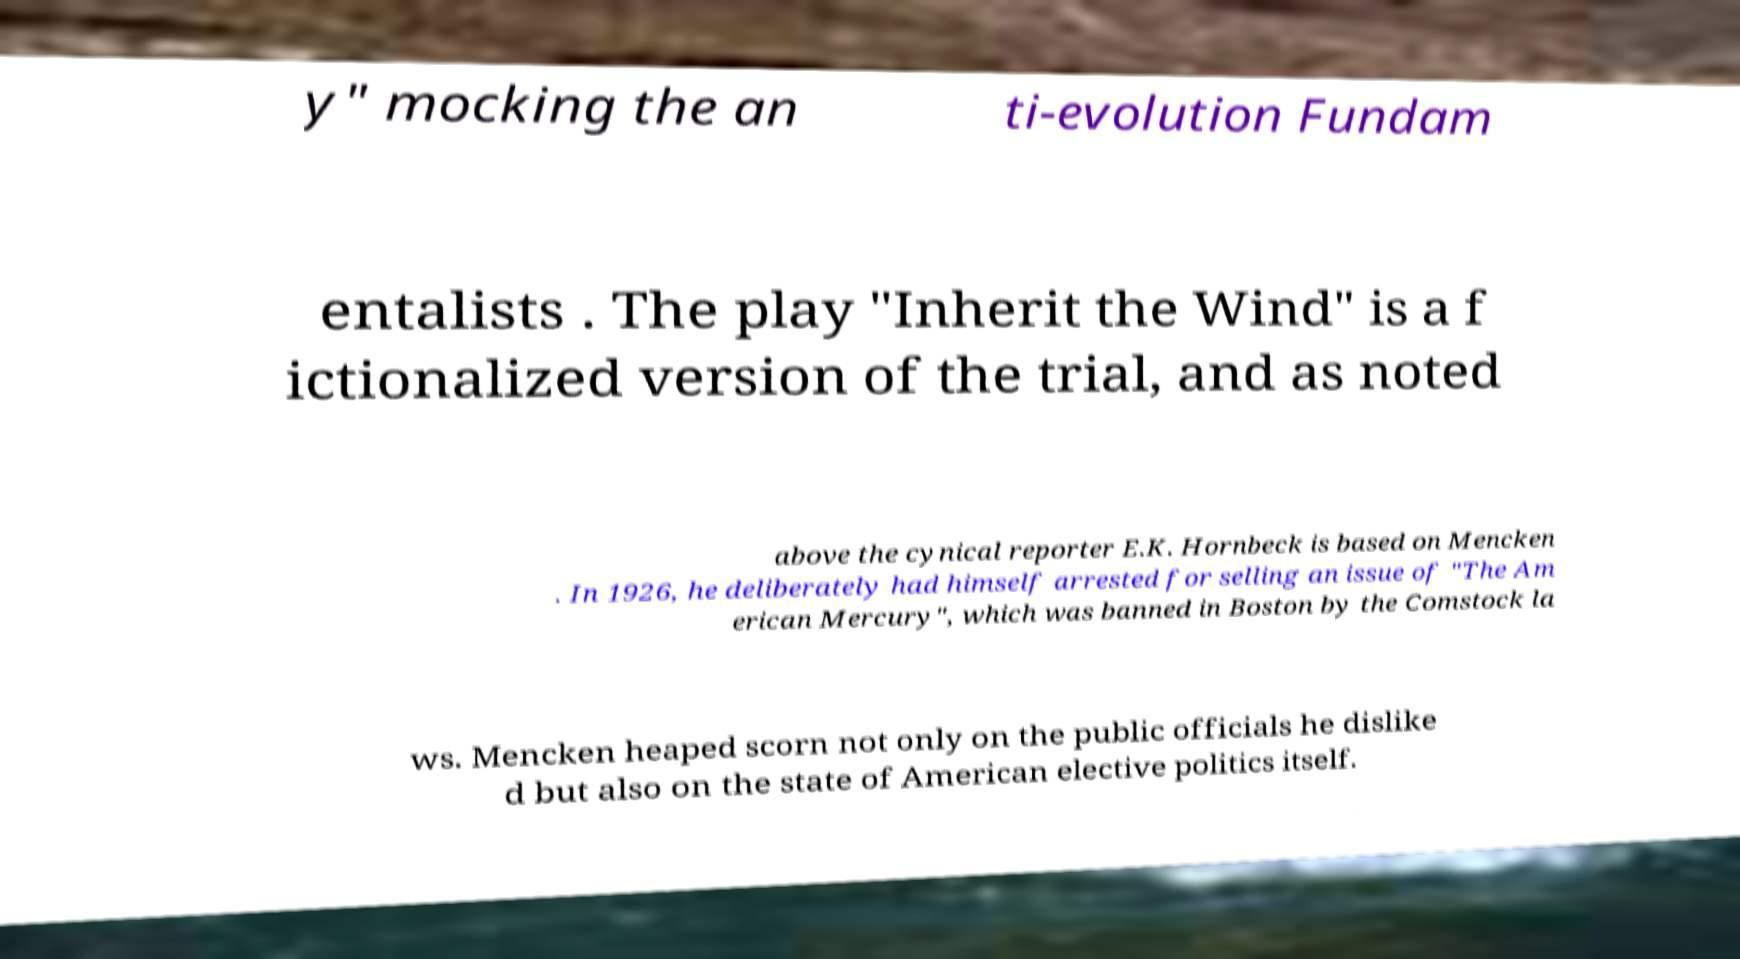Could you assist in decoding the text presented in this image and type it out clearly? y" mocking the an ti-evolution Fundam entalists . The play "Inherit the Wind" is a f ictionalized version of the trial, and as noted above the cynical reporter E.K. Hornbeck is based on Mencken . In 1926, he deliberately had himself arrested for selling an issue of "The Am erican Mercury", which was banned in Boston by the Comstock la ws. Mencken heaped scorn not only on the public officials he dislike d but also on the state of American elective politics itself. 